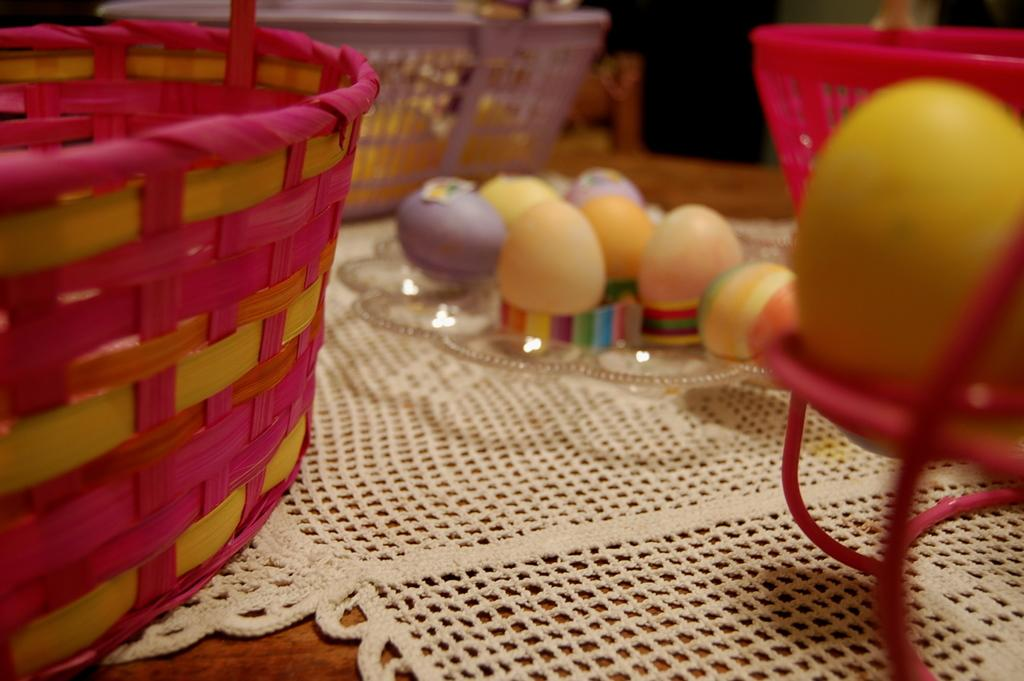What is the main piece of furniture in the image? There is a table in the image. What is placed on the table? There are baskets and eggs on the table. What is covering the table? The table is covered with a mat. Can you describe the background of the image? The background of the image is blurred. What type of curve can be seen on the desk in the image? There is no desk present in the image, and therefore no curve can be observed. 